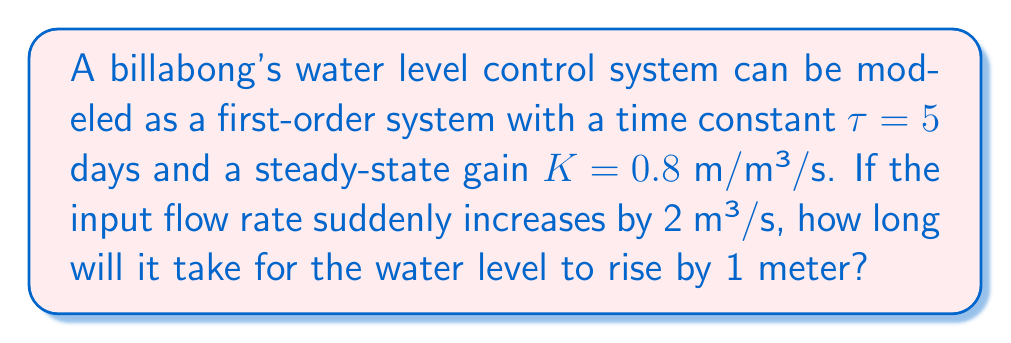What is the answer to this math problem? To solve this problem, we need to use the first-order system response equation and the given parameters. Let's break it down step-by-step:

1. The transfer function of a first-order system is given by:

   $$G(s) = \frac{K}{\tau s + 1}$$

   where $K$ is the steady-state gain and $\tau$ is the time constant.

2. The step response of a first-order system is described by:

   $$y(t) = K \cdot \Delta u \cdot (1 - e^{-t/\tau})$$

   where $\Delta u$ is the magnitude of the input step change.

3. We are given:
   - $K = 0.8$ m/m³/s
   - $\tau = 5$ days
   - $\Delta u = 2$ m³/s
   - Target water level rise = 1 meter

4. Let's substitute these values into the equation:

   $$1 = 0.8 \cdot 2 \cdot (1 - e^{-t/5})$$

5. Simplify:

   $$1 = 1.6 \cdot (1 - e^{-t/5})$$

6. Solve for $(1 - e^{-t/5})$:

   $$\frac{1}{1.6} = 1 - e^{-t/5}$$
   $$0.625 = 1 - e^{-t/5}$$
   $$e^{-t/5} = 0.375$$

7. Take the natural logarithm of both sides:

   $$-t/5 = \ln(0.375)$$

8. Solve for $t$:

   $$t = -5 \cdot \ln(0.375)$$
   $$t \approx 4.95 \text{ days}$$

Therefore, it will take approximately 4.95 days for the water level to rise by 1 meter.
Answer: 4.95 days 